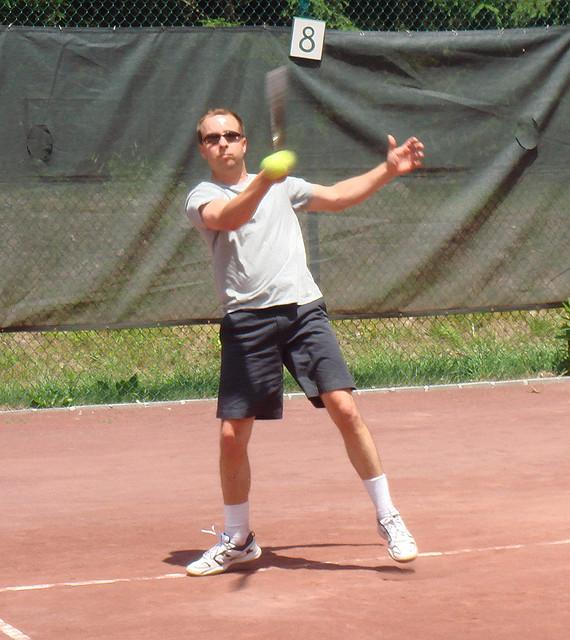Why is the man wearing glasses?

Choices:
A) fashion
B) dress code
C) block sunlight
D) halloween costume block sunlight 